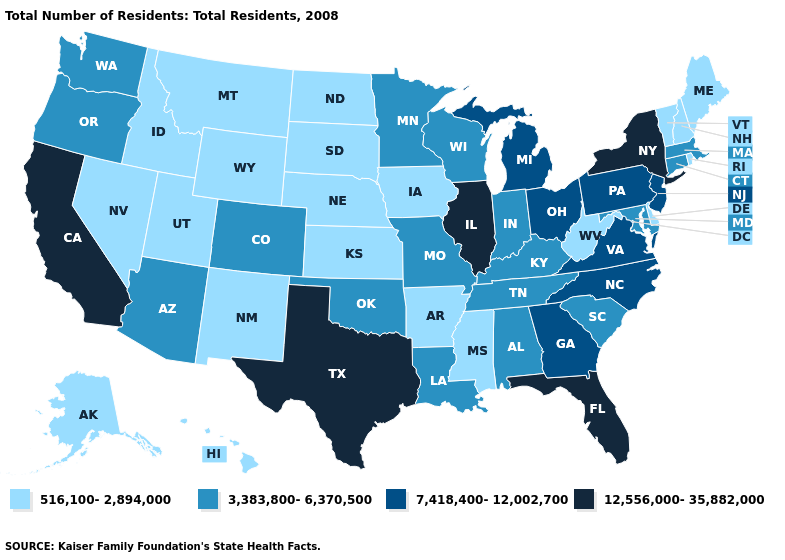Name the states that have a value in the range 7,418,400-12,002,700?
Concise answer only. Georgia, Michigan, New Jersey, North Carolina, Ohio, Pennsylvania, Virginia. Which states have the highest value in the USA?
Give a very brief answer. California, Florida, Illinois, New York, Texas. Does Ohio have the lowest value in the USA?
Short answer required. No. What is the highest value in the USA?
Be succinct. 12,556,000-35,882,000. What is the lowest value in the West?
Give a very brief answer. 516,100-2,894,000. What is the lowest value in the MidWest?
Write a very short answer. 516,100-2,894,000. What is the value of Delaware?
Answer briefly. 516,100-2,894,000. What is the highest value in the USA?
Keep it brief. 12,556,000-35,882,000. What is the value of Nebraska?
Give a very brief answer. 516,100-2,894,000. Among the states that border Iowa , does Illinois have the highest value?
Concise answer only. Yes. Does New York have the highest value in the Northeast?
Short answer required. Yes. Does California have a lower value than Missouri?
Quick response, please. No. Name the states that have a value in the range 516,100-2,894,000?
Short answer required. Alaska, Arkansas, Delaware, Hawaii, Idaho, Iowa, Kansas, Maine, Mississippi, Montana, Nebraska, Nevada, New Hampshire, New Mexico, North Dakota, Rhode Island, South Dakota, Utah, Vermont, West Virginia, Wyoming. Name the states that have a value in the range 516,100-2,894,000?
Write a very short answer. Alaska, Arkansas, Delaware, Hawaii, Idaho, Iowa, Kansas, Maine, Mississippi, Montana, Nebraska, Nevada, New Hampshire, New Mexico, North Dakota, Rhode Island, South Dakota, Utah, Vermont, West Virginia, Wyoming. Name the states that have a value in the range 7,418,400-12,002,700?
Quick response, please. Georgia, Michigan, New Jersey, North Carolina, Ohio, Pennsylvania, Virginia. 